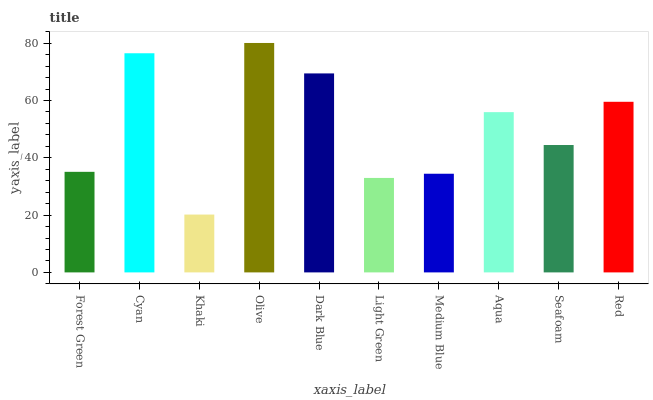Is Khaki the minimum?
Answer yes or no. Yes. Is Olive the maximum?
Answer yes or no. Yes. Is Cyan the minimum?
Answer yes or no. No. Is Cyan the maximum?
Answer yes or no. No. Is Cyan greater than Forest Green?
Answer yes or no. Yes. Is Forest Green less than Cyan?
Answer yes or no. Yes. Is Forest Green greater than Cyan?
Answer yes or no. No. Is Cyan less than Forest Green?
Answer yes or no. No. Is Aqua the high median?
Answer yes or no. Yes. Is Seafoam the low median?
Answer yes or no. Yes. Is Dark Blue the high median?
Answer yes or no. No. Is Cyan the low median?
Answer yes or no. No. 